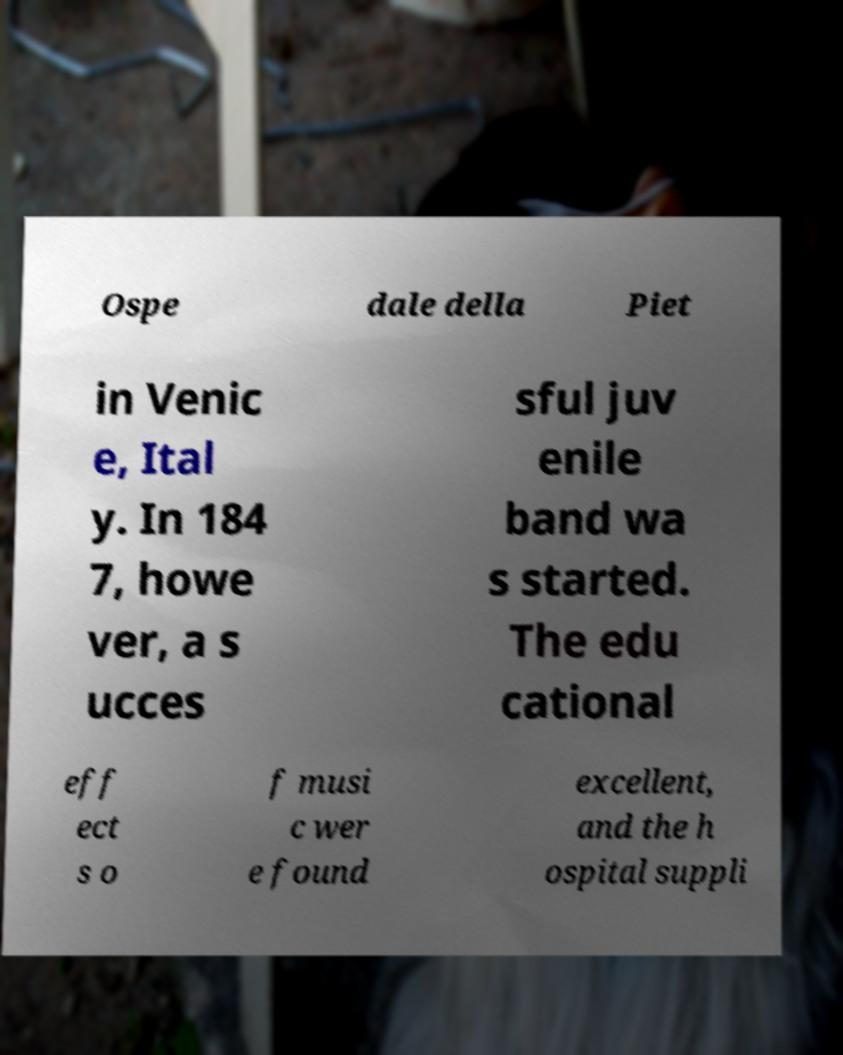What messages or text are displayed in this image? I need them in a readable, typed format. Ospe dale della Piet in Venic e, Ital y. In 184 7, howe ver, a s ucces sful juv enile band wa s started. The edu cational eff ect s o f musi c wer e found excellent, and the h ospital suppli 